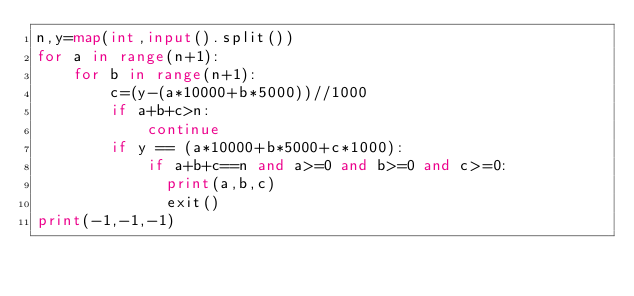Convert code to text. <code><loc_0><loc_0><loc_500><loc_500><_Python_>n,y=map(int,input().split())
for a in range(n+1):
    for b in range(n+1):
        c=(y-(a*10000+b*5000))//1000
        if a+b+c>n:
            continue
        if y == (a*10000+b*5000+c*1000):
            if a+b+c==n and a>=0 and b>=0 and c>=0:
              print(a,b,c)
              exit()
print(-1,-1,-1)</code> 